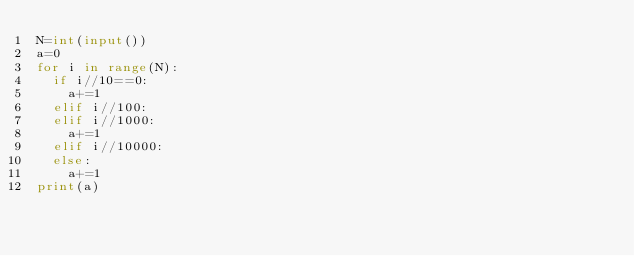<code> <loc_0><loc_0><loc_500><loc_500><_Python_>N=int(input())
a=0
for i in range(N):
  if i//10==0:
    a+=1
  elif i//100:
  elif i//1000:
    a+=1
  elif i//10000:
  else:
    a+=1
print(a)
  </code> 